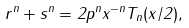<formula> <loc_0><loc_0><loc_500><loc_500>r ^ { n } + s ^ { n } = 2 p ^ { n } x ^ { - n } T _ { n } ( x / 2 ) ,</formula> 